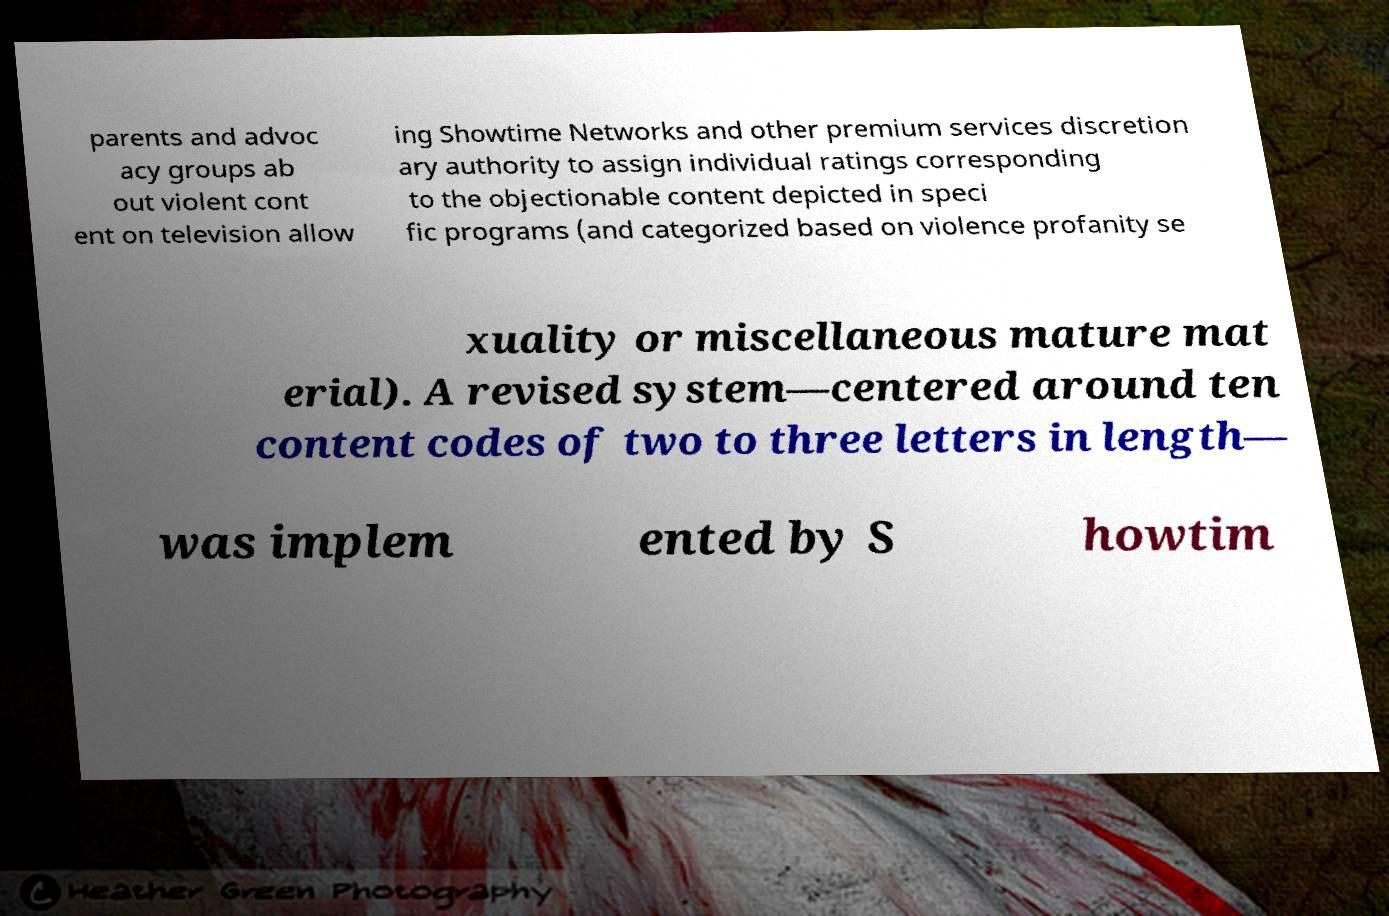Can you read and provide the text displayed in the image?This photo seems to have some interesting text. Can you extract and type it out for me? parents and advoc acy groups ab out violent cont ent on television allow ing Showtime Networks and other premium services discretion ary authority to assign individual ratings corresponding to the objectionable content depicted in speci fic programs (and categorized based on violence profanity se xuality or miscellaneous mature mat erial). A revised system—centered around ten content codes of two to three letters in length— was implem ented by S howtim 